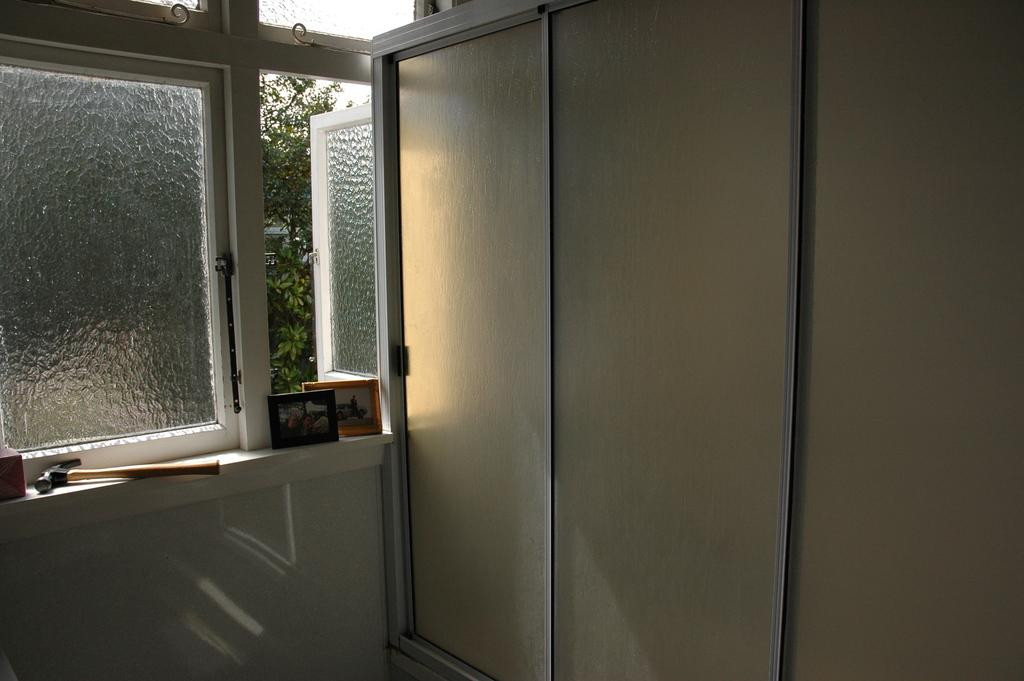What type of transparent barrier is present in the image? There is a glass window in the image. What can be seen through the glass window? Trees are visible through the glass window. What decorative items are on the wall in the image? There are photo frames on the wall. What tool is present beside the wall in the image? A hammer is present beside the wall. What is the primary architectural feature in the image? There is a wall in the image. How many sticks are being used to hold the ticket in the image? There are no sticks or tickets present in the image. What type of key is being used to open the door in the image? There is no door or key present in the image. 